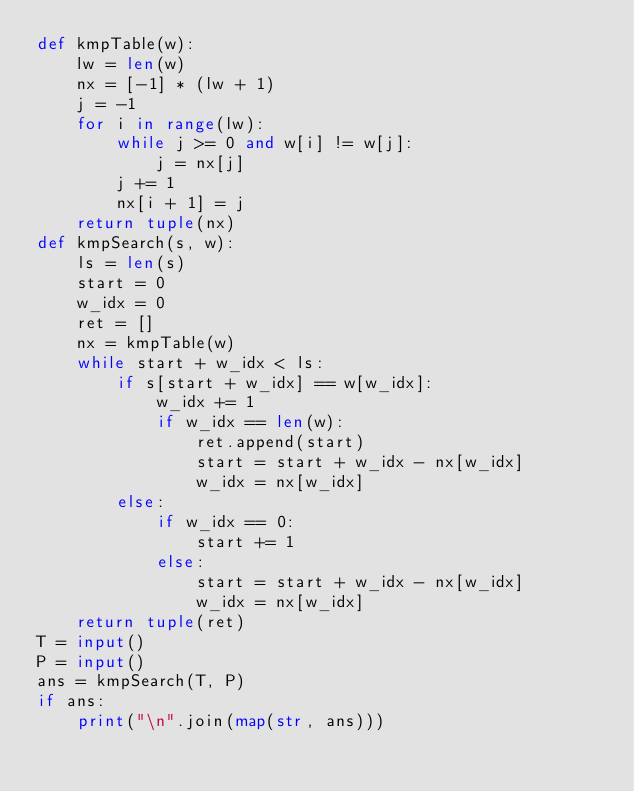<code> <loc_0><loc_0><loc_500><loc_500><_Python_>def kmpTable(w):
    lw = len(w)
    nx = [-1] * (lw + 1)
    j = -1
    for i in range(lw):
        while j >= 0 and w[i] != w[j]:
            j = nx[j]
        j += 1
        nx[i + 1] = j
    return tuple(nx)
def kmpSearch(s, w):
    ls = len(s)
    start = 0
    w_idx = 0
    ret = []
    nx = kmpTable(w)
    while start + w_idx < ls:
        if s[start + w_idx] == w[w_idx]:
            w_idx += 1
            if w_idx == len(w):
                ret.append(start)
                start = start + w_idx - nx[w_idx]
                w_idx = nx[w_idx]
        else:
            if w_idx == 0:
                start += 1
            else:
                start = start + w_idx - nx[w_idx]
                w_idx = nx[w_idx]
    return tuple(ret)
T = input()
P = input()
ans = kmpSearch(T, P)
if ans:
    print("\n".join(map(str, ans)))	

</code> 